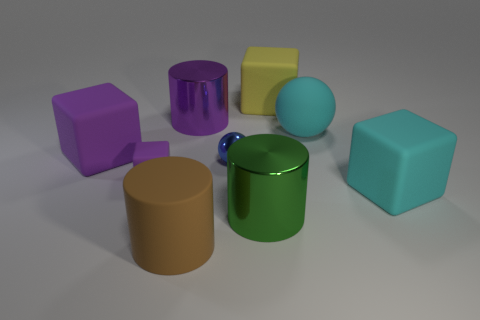How many cyan things are either large matte cylinders or big spheres? In the image, we can observe various objects with different shapes and colors, including a cyan colored large matte cylinder. Counting all items that match the description, it appears there are no items that are both cyan and big spheres, and just one item that is a cyan large matte cylinder. 